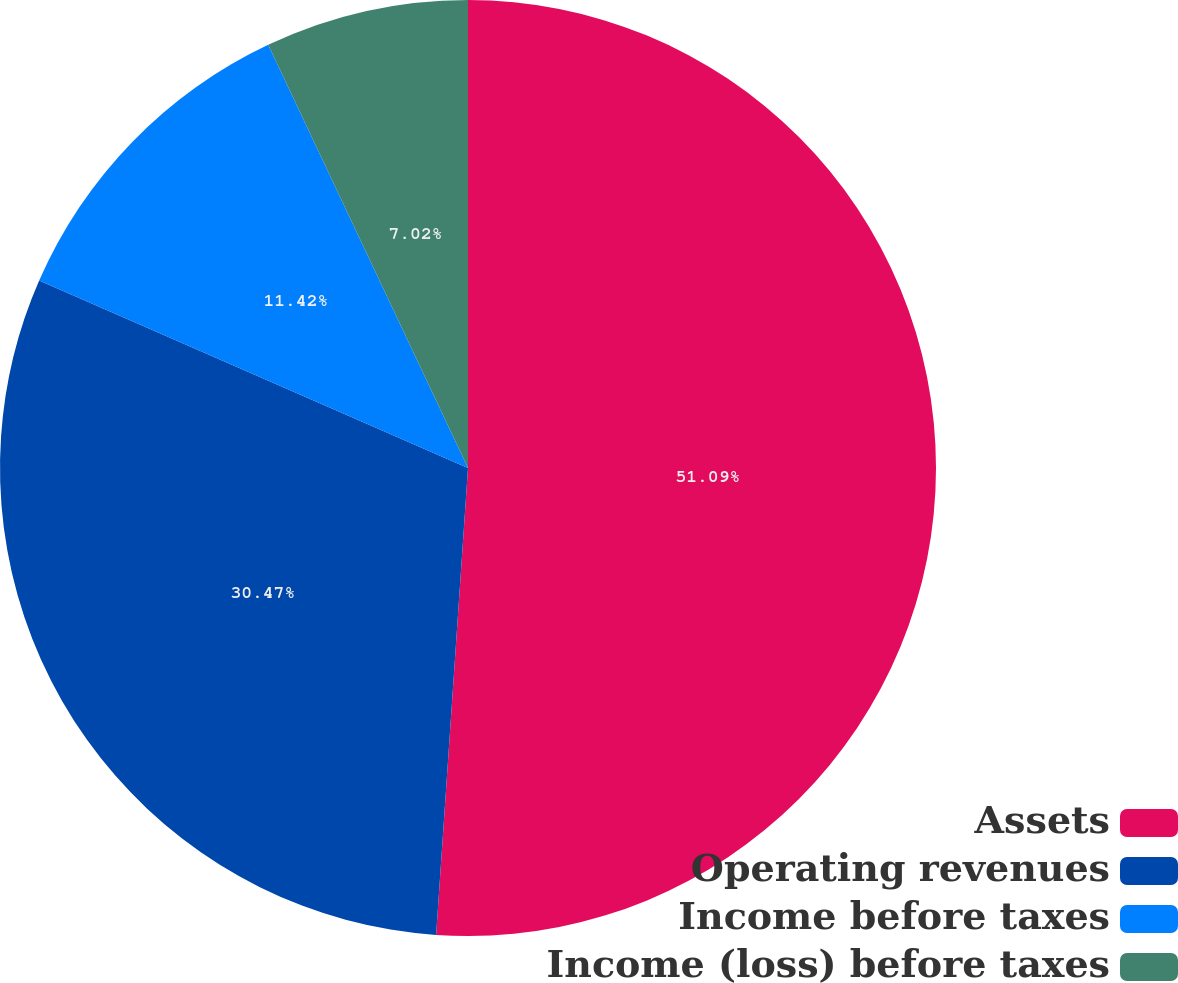Convert chart to OTSL. <chart><loc_0><loc_0><loc_500><loc_500><pie_chart><fcel>Assets<fcel>Operating revenues<fcel>Income before taxes<fcel>Income (loss) before taxes<nl><fcel>51.08%<fcel>30.47%<fcel>11.42%<fcel>7.02%<nl></chart> 